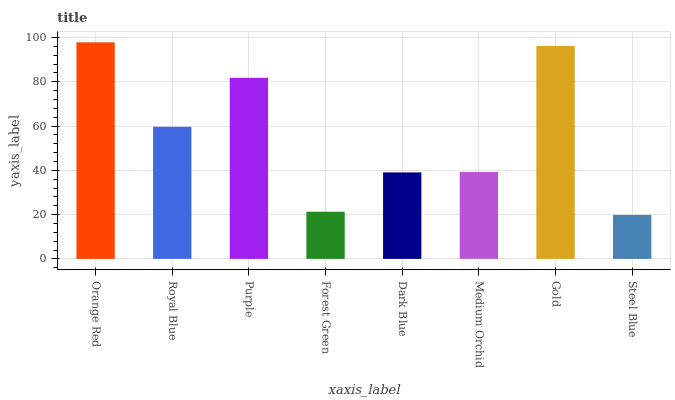Is Steel Blue the minimum?
Answer yes or no. Yes. Is Orange Red the maximum?
Answer yes or no. Yes. Is Royal Blue the minimum?
Answer yes or no. No. Is Royal Blue the maximum?
Answer yes or no. No. Is Orange Red greater than Royal Blue?
Answer yes or no. Yes. Is Royal Blue less than Orange Red?
Answer yes or no. Yes. Is Royal Blue greater than Orange Red?
Answer yes or no. No. Is Orange Red less than Royal Blue?
Answer yes or no. No. Is Royal Blue the high median?
Answer yes or no. Yes. Is Medium Orchid the low median?
Answer yes or no. Yes. Is Steel Blue the high median?
Answer yes or no. No. Is Dark Blue the low median?
Answer yes or no. No. 